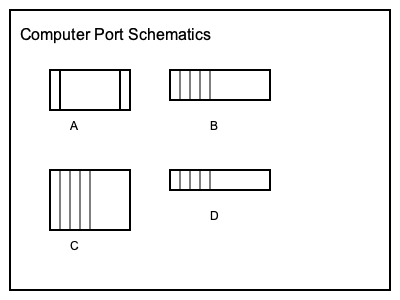As a leading tech company relying on specialized chips for AI-powered products, it's crucial to understand various computer ports. Identify the port represented by schematic B in the image, which is commonly used for high-definition video and audio transmission in modern computing devices. To identify the port represented by schematic B, let's analyze the characteristics of each schematic:

1. Schematic A: Rectangular shape with two distinct sections, typical of USB Type-A ports.

2. Schematic B: Wide rectangular shape with multiple small connectors inside. This is characteristic of an HDMI (High-Definition Multimedia Interface) port, which is used for high-quality digital video and audio transmission.

3. Schematic C: Larger rectangular shape with multiple small connectors, resembling an Ethernet (RJ45) port used for network connections.

4. Schematic D: Slim, elongated rectangle with symmetrical design, indicative of a USB Type-C port.

The question asks about a port commonly used for high-definition video and audio transmission. Among these options, HDMI is the primary standard for transmitting uncompressed video and audio data in consumer electronics and computer systems.

Therefore, schematic B represents an HDMI port, which aligns with the description in the question.
Answer: HDMI 